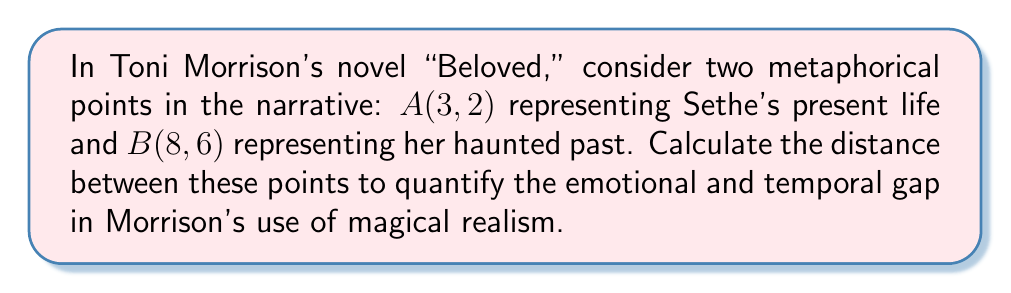Could you help me with this problem? To calculate the distance between two points in a 2D plane, we use the distance formula derived from the Pythagorean theorem:

$$d = \sqrt{(x_2 - x_1)^2 + (y_2 - y_1)^2}$$

Where $(x_1, y_1)$ are the coordinates of the first point and $(x_2, y_2)$ are the coordinates of the second point.

For our metaphorical points:
A(3, 2) represents Sethe's present life: $x_1 = 3, y_1 = 2$
B(8, 6) represents her haunted past: $x_2 = 8, y_2 = 6$

Let's substitute these values into the formula:

$$d = \sqrt{(8 - 3)^2 + (6 - 2)^2}$$

Simplify the expressions inside the parentheses:
$$d = \sqrt{5^2 + 4^2}$$

Calculate the squares:
$$d = \sqrt{25 + 16}$$

Add the terms under the square root:
$$d = \sqrt{41}$$

This irrational number represents the metaphorical distance between Sethe's present and her past in Morrison's narrative.

[asy]
unitsize(1cm);
draw((-1,-1)--(10,7),gray);
draw((-1,0)--(10,0),gray);
draw((0,-1)--(0,7),gray);
dot((3,2));
dot((8,6));
label("A(3,2)",(3,2),SE);
label("B(8,6)",(8,6),NW);
draw((3,2)--(8,6),red);
[/asy]
Answer: $\sqrt{41}$ 